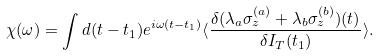<formula> <loc_0><loc_0><loc_500><loc_500>\chi ( \omega ) = \int d ( t - t _ { 1 } ) e ^ { i \omega ( t - t _ { 1 } ) } \langle \frac { \delta ( \lambda _ { a } \sigma _ { z } ^ { ( a ) } + \lambda _ { b } \sigma _ { z } ^ { ( b ) } ) ( t ) } { \delta I _ { T } ( t _ { 1 } ) } \rangle .</formula> 